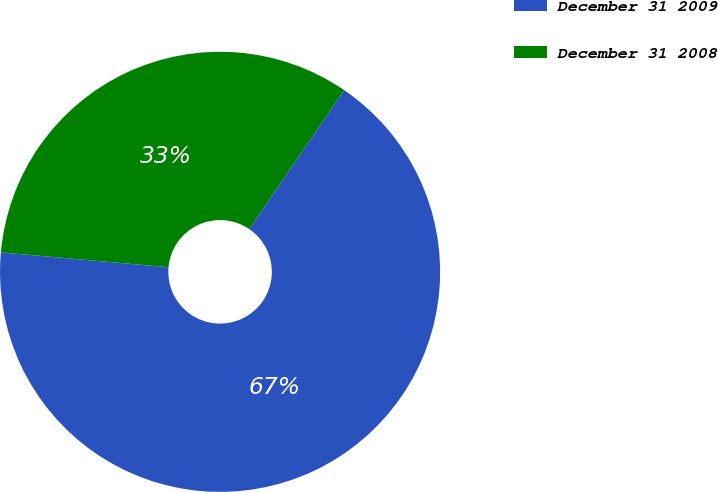Convert chart. <chart><loc_0><loc_0><loc_500><loc_500><pie_chart><fcel>December 31 2009<fcel>December 31 2008<nl><fcel>66.87%<fcel>33.13%<nl></chart> 